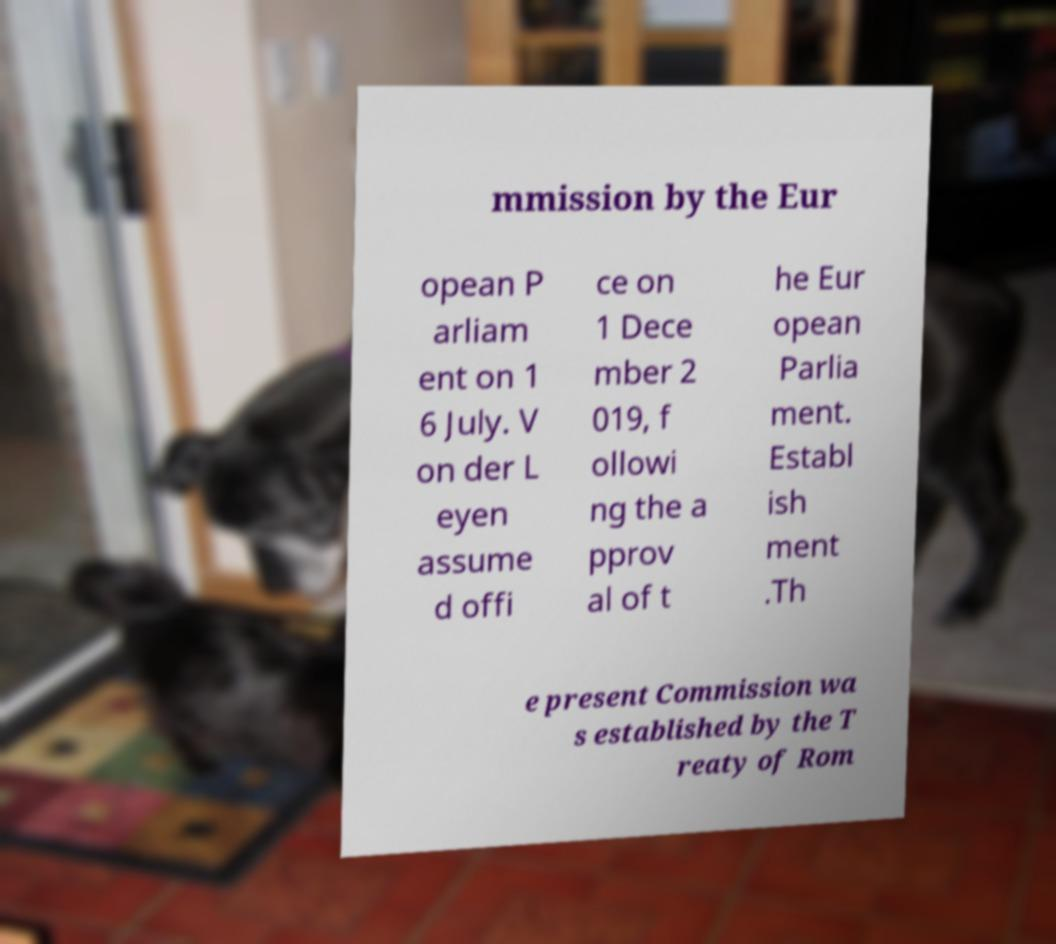There's text embedded in this image that I need extracted. Can you transcribe it verbatim? mmission by the Eur opean P arliam ent on 1 6 July. V on der L eyen assume d offi ce on 1 Dece mber 2 019, f ollowi ng the a pprov al of t he Eur opean Parlia ment. Establ ish ment .Th e present Commission wa s established by the T reaty of Rom 